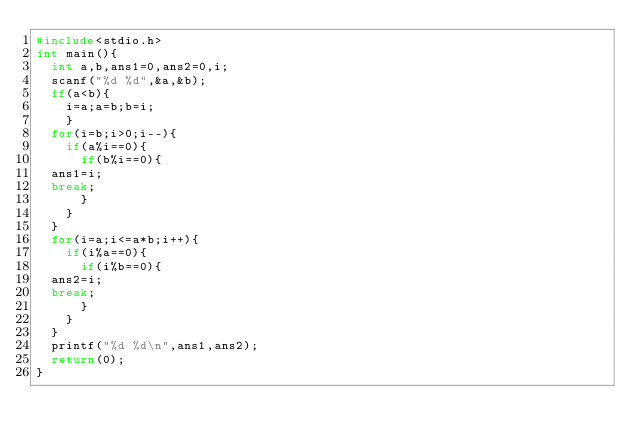<code> <loc_0><loc_0><loc_500><loc_500><_C_>#include<stdio.h>
int main(){
  int a,b,ans1=0,ans2=0,i;
  scanf("%d %d",&a,&b);
  if(a<b){
    i=a;a=b;b=i;
    }   
  for(i=b;i>0;i--){
    if(a%i==0){
      if(b%i==0){
	ans1=i;
	break;
      }
    }
  }
  for(i=a;i<=a*b;i++){
    if(i%a==0){
      if(i%b==0){
	ans2=i;
	break;
      }
    }
  }
  printf("%d %d\n",ans1,ans2);
  return(0);
}</code> 